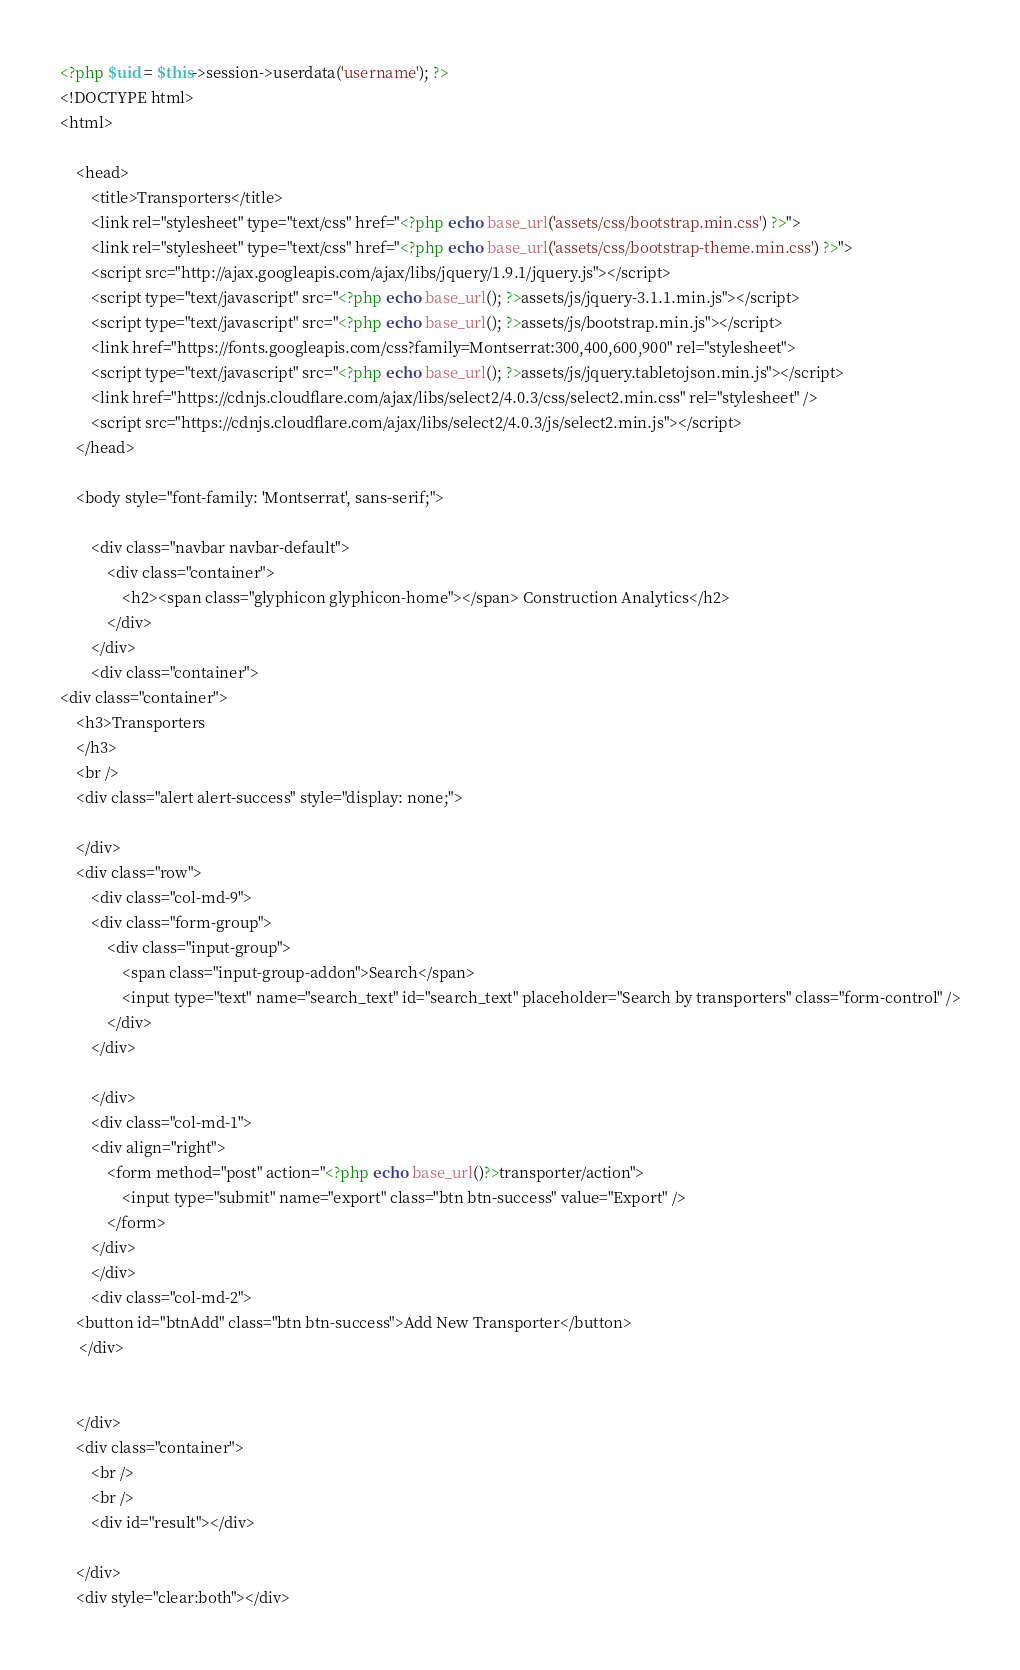Convert code to text. <code><loc_0><loc_0><loc_500><loc_500><_PHP_><?php $uid = $this->session->userdata('username'); ?>
<!DOCTYPE html>
<html>

    <head>
        <title>Transporters</title>
        <link rel="stylesheet" type="text/css" href="<?php echo base_url('assets/css/bootstrap.min.css') ?>">
        <link rel="stylesheet" type="text/css" href="<?php echo base_url('assets/css/bootstrap-theme.min.css') ?>">
        <script src="http://ajax.googleapis.com/ajax/libs/jquery/1.9.1/jquery.js"></script>
        <script type="text/javascript" src="<?php echo base_url(); ?>assets/js/jquery-3.1.1.min.js"></script>
        <script type="text/javascript" src="<?php echo base_url(); ?>assets/js/bootstrap.min.js"></script>
        <link href="https://fonts.googleapis.com/css?family=Montserrat:300,400,600,900" rel="stylesheet">
        <script type="text/javascript" src="<?php echo base_url(); ?>assets/js/jquery.tabletojson.min.js"></script>
        <link href="https://cdnjs.cloudflare.com/ajax/libs/select2/4.0.3/css/select2.min.css" rel="stylesheet" />
        <script src="https://cdnjs.cloudflare.com/ajax/libs/select2/4.0.3/js/select2.min.js"></script>
    </head>

    <body style="font-family: 'Montserrat', sans-serif;">

        <div class="navbar navbar-default">
            <div class="container">
                <h2><span class="glyphicon glyphicon-home"></span> Construction Analytics</h2>
            </div>
        </div>
        <div class="container">
<div class="container">
    <h3>Transporters
    </h3>
    <br />
    <div class="alert alert-success" style="display: none;">

    </div>
    <div class="row">
        <div class="col-md-9">
        <div class="form-group">
            <div class="input-group">
                <span class="input-group-addon">Search</span>
                <input type="text" name="search_text" id="search_text" placeholder="Search by transporters" class="form-control" />
            </div>
        </div>
            
        </div>
        <div class="col-md-1">
        <div align="right">
            <form method="post" action="<?php echo base_url()?>transporter/action">
                <input type="submit" name="export" class="btn btn-success" value="Export" />
            </form>
        </div>
        </div>
        <div class="col-md-2">
    <button id="btnAdd" class="btn btn-success">Add New Transporter</button>
     </div>
        
       
    </div>
    <div class="container">
        <br />
        <br />
        <div id="result"></div>

    </div>
    <div style="clear:both"></div>
</code> 